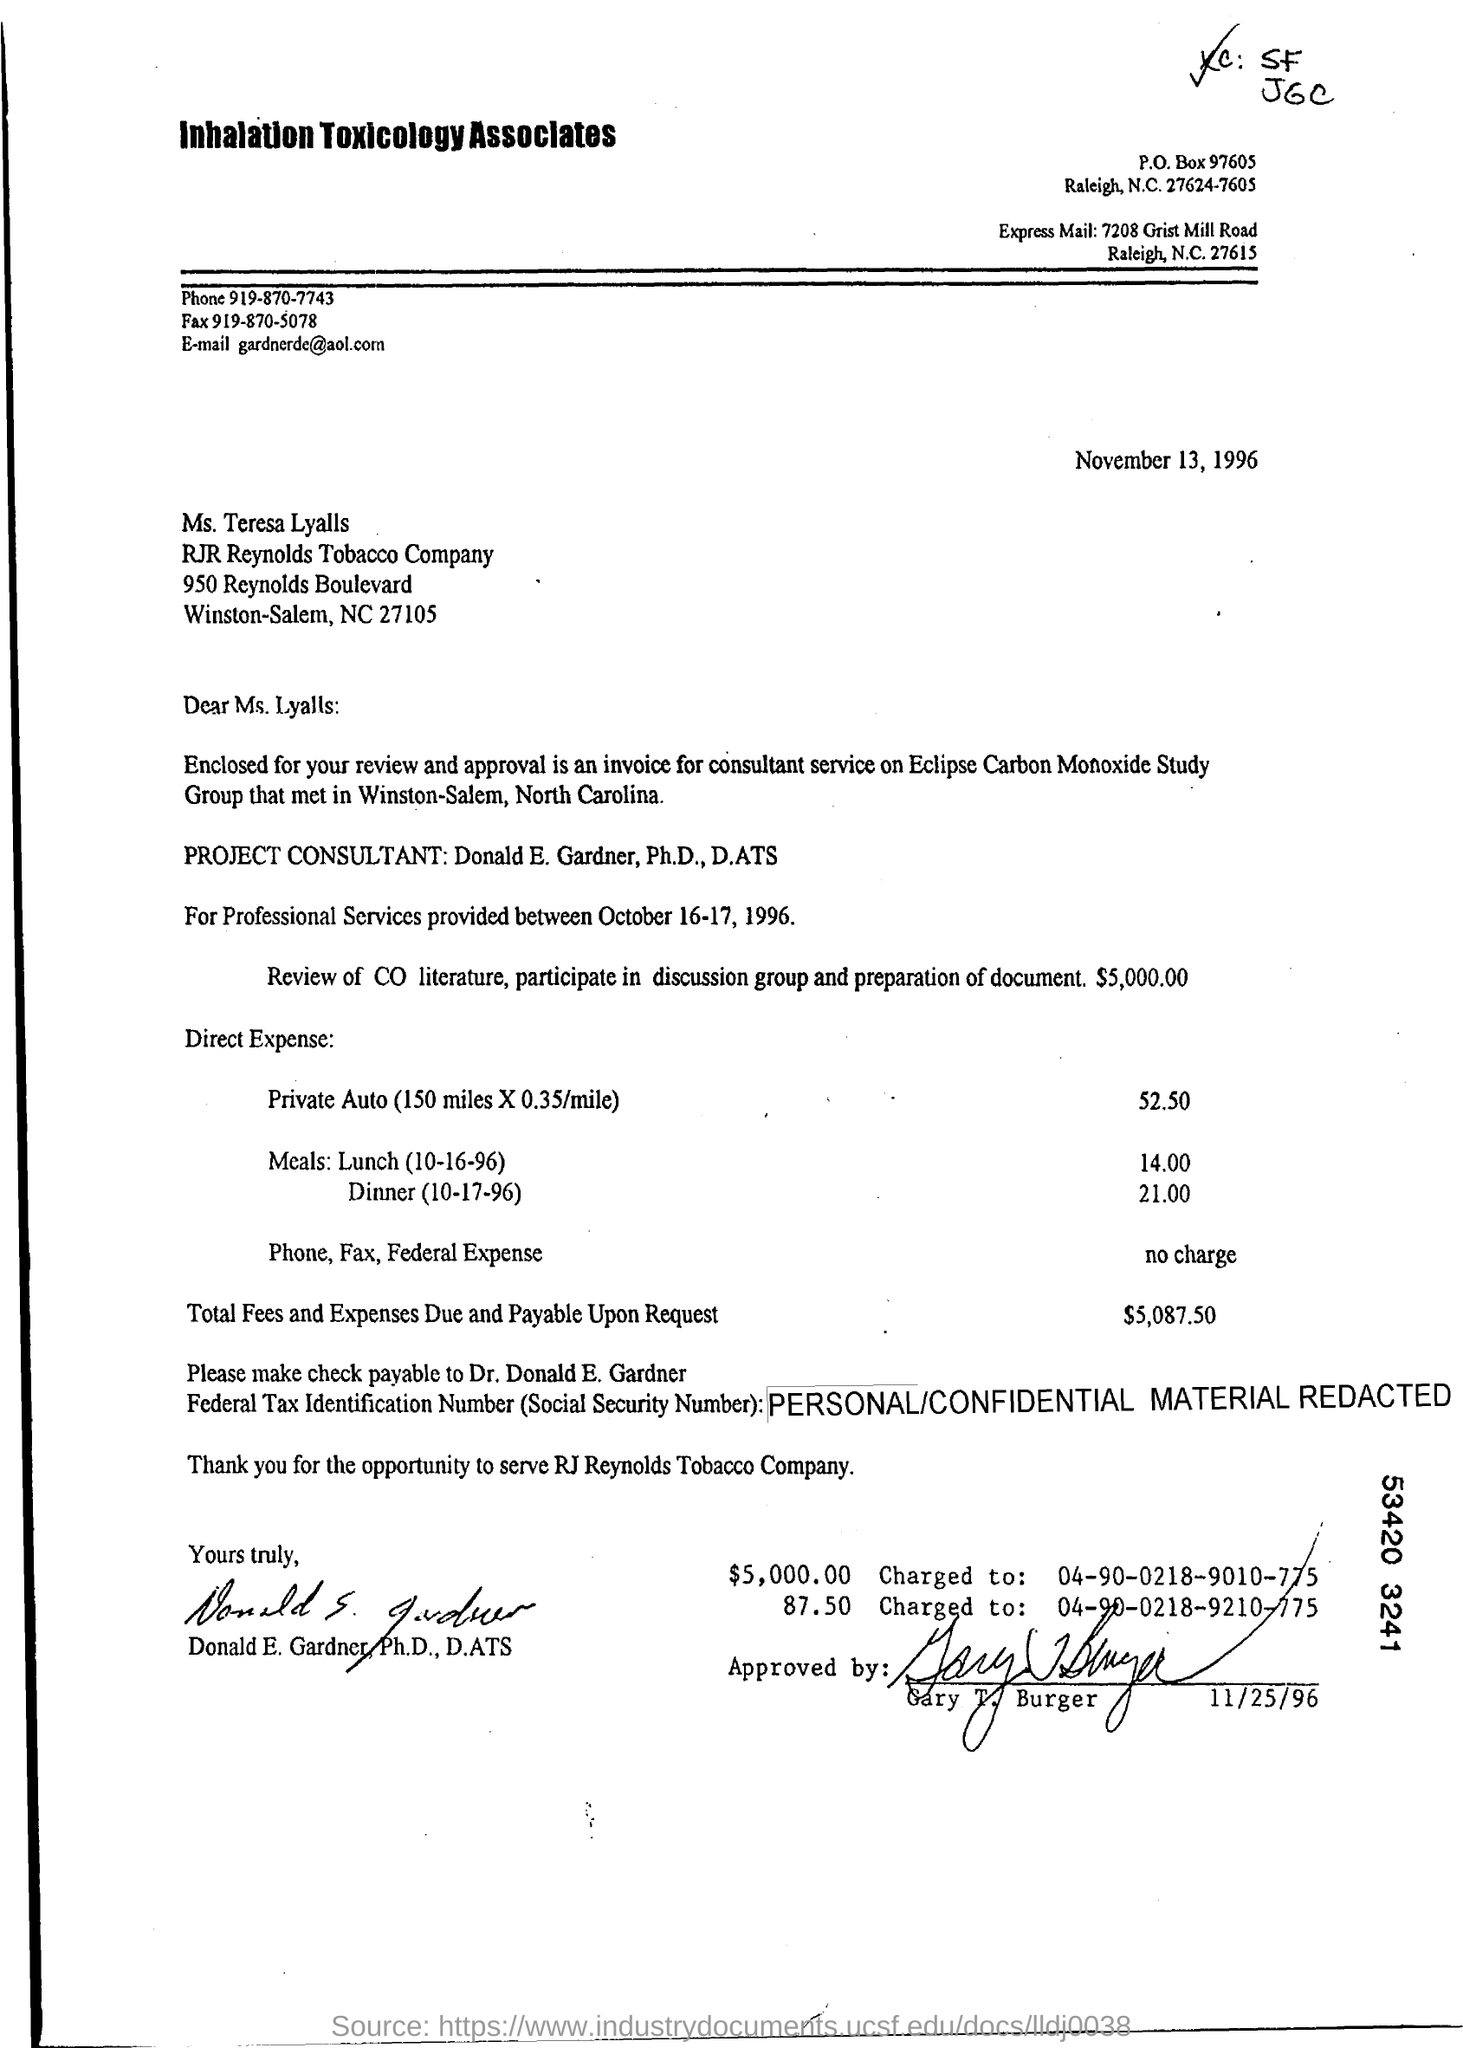What is the phone number ?
Provide a succinct answer. 919-870-7743. What is the fax number ?
Offer a very short reply. 919-870-5078. 